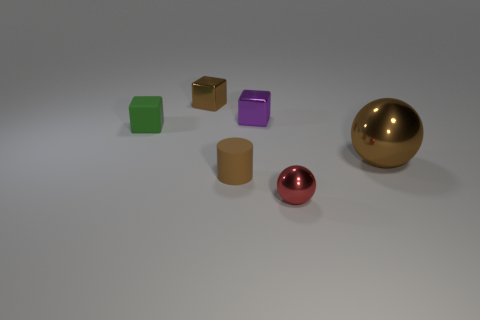Add 1 red metallic things. How many objects exist? 7 Subtract all red blocks. Subtract all red balls. How many blocks are left? 3 Subtract all cylinders. How many objects are left? 5 Subtract all brown cylinders. Subtract all tiny purple things. How many objects are left? 4 Add 5 tiny green rubber things. How many tiny green rubber things are left? 6 Add 2 cyan shiny objects. How many cyan shiny objects exist? 2 Subtract 0 purple spheres. How many objects are left? 6 